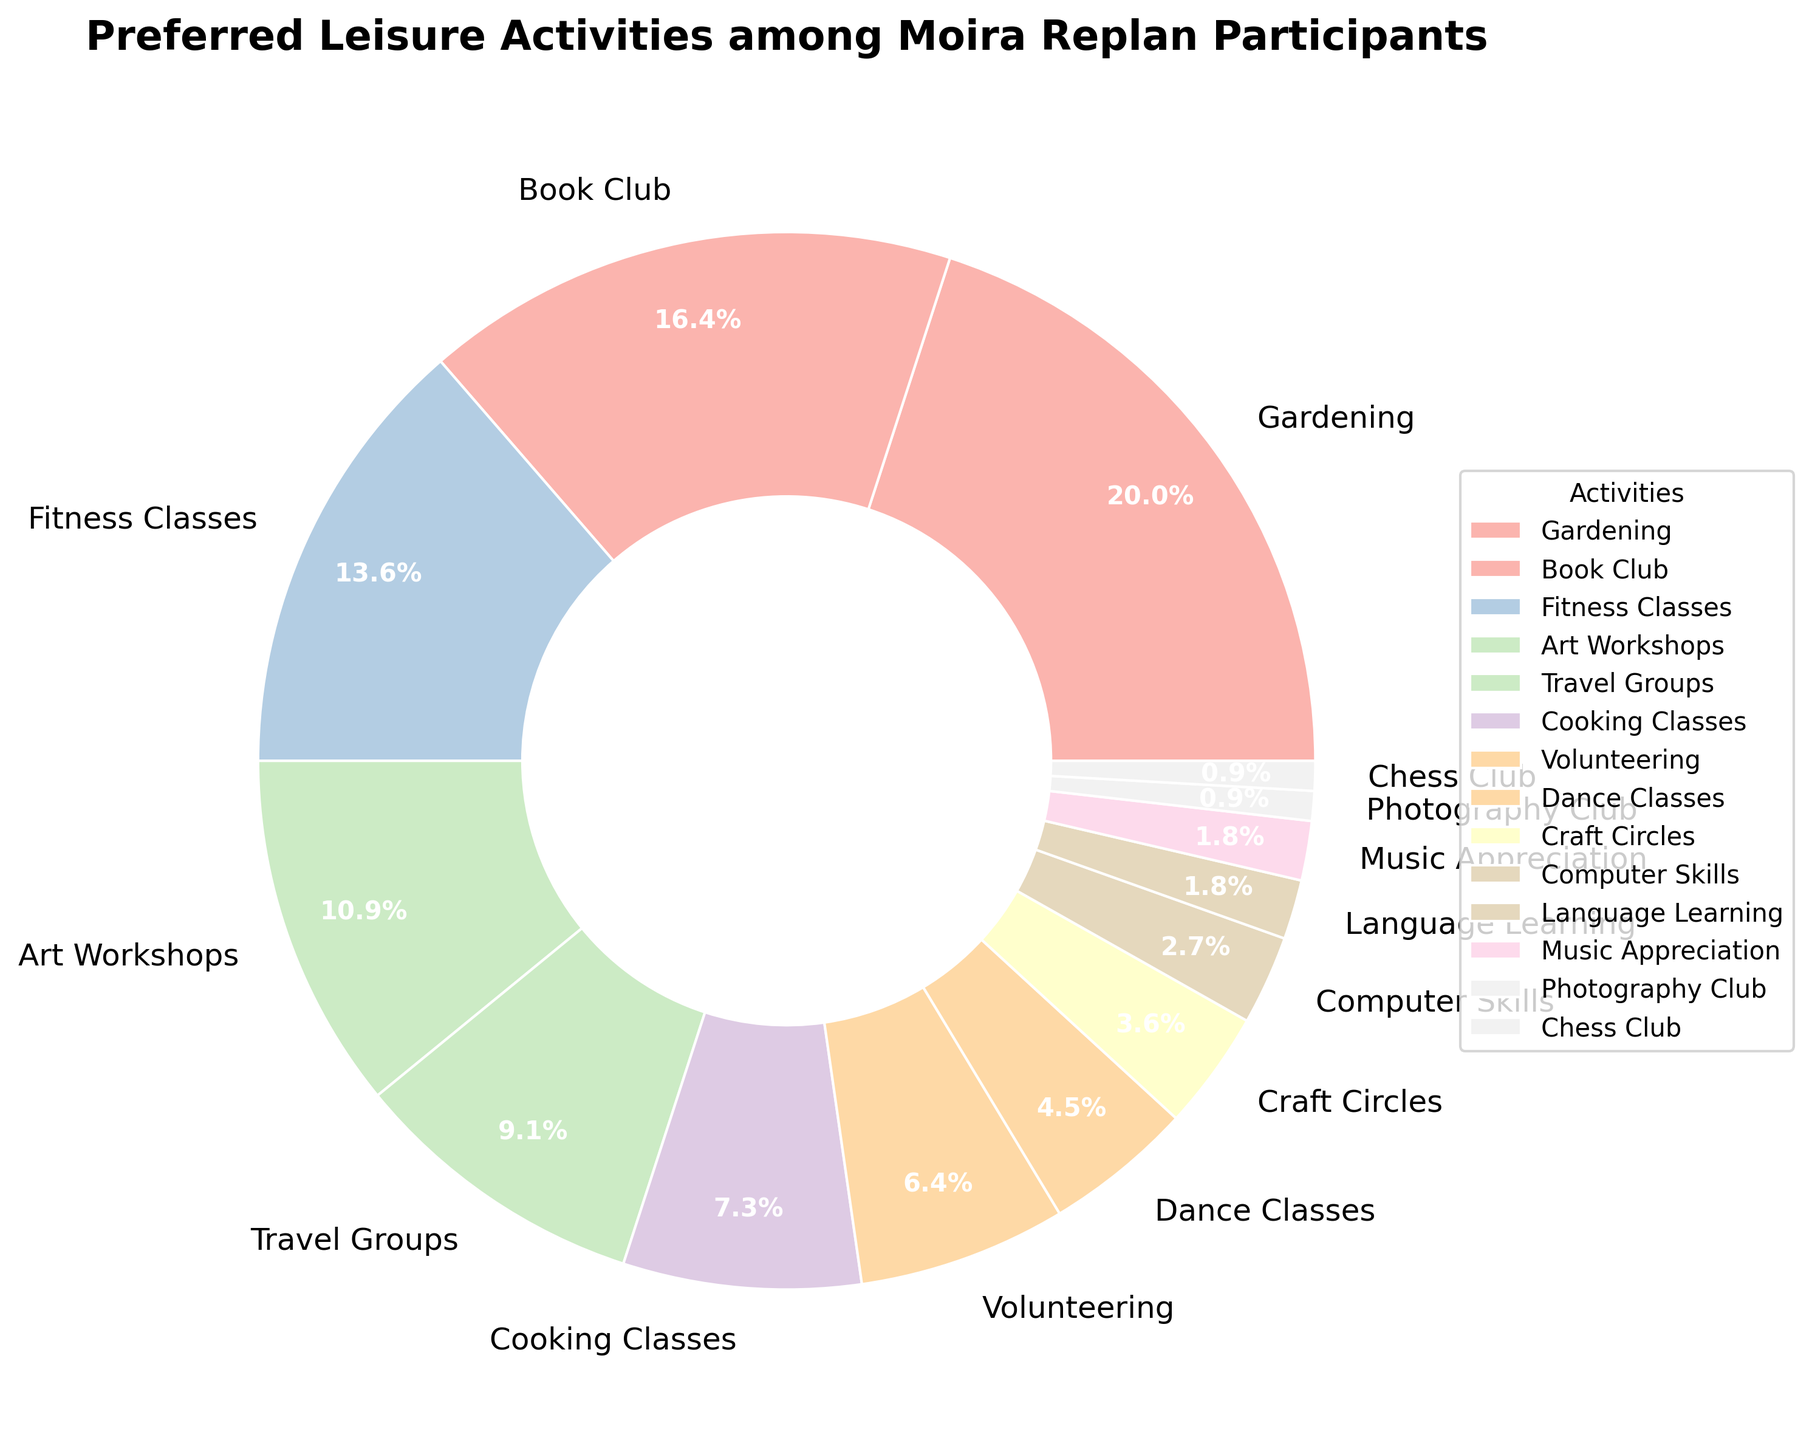What activity has the highest percentage among Moira Replan participants? According to the pie chart, Gardening has the largest wedge and is listed at the top with 22%.
Answer: Gardening What's the combined percentage for Fitness Classes, Cooking Classes, and Dance Classes? Fitness Classes is 15%, Cooking Classes is 8%, and Dance Classes is 5%. Adding them together, 15 + 8 + 5 = 28%.
Answer: 28% Which activity has a larger percentage, Volunteering or Book Club? Volunteering has 7% while Book Club has 18%. Therefore, Book Club has a larger percentage.
Answer: Book Club Compare the percentages of Art Workshops and Travel Groups. Which one is greater? Art Workshops have 12% and Travel Groups have 10%. Art Workshops have a greater percentage.
Answer: Art Workshops Which activities account for only 1% of the preferences? The pie chart shows Photography Club and Chess Club both have a 1% share.
Answer: Photography Club and Chess Club What's the difference in percentage between the top activity and the least preferred activity? Gardening, the top activity, has 22%, and both Photography Club and Chess Club, the least, have 1%. The difference is 22% - 1% = 21%.
Answer: 21% What is the total percentage for activities related to arts and crafts (Art Workshops, Craft Circles, and Photography Club)? Art Workshops have 12%, Craft Circles have 4%, and Photography Club has 1%. Adding them together, 12 + 4 + 1 = 17%.
Answer: 17% Which is more popular: Language Learning or Computer Skills? The pie chart shows that Computer Skills have 3% whereas Language Learning has 2%. Hence, Computer Skills are more popular.
Answer: Computer Skills 